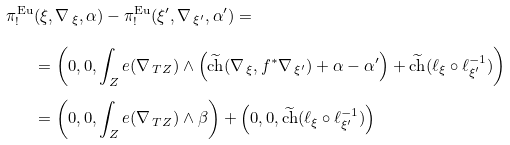<formula> <loc_0><loc_0><loc_500><loc_500>\pi ^ { \text {Eu} } _ { ! } & ( \xi , \nabla _ { \, \xi } , \alpha ) - \pi ^ { \text {Eu} } _ { ! } ( \xi ^ { \prime } , \nabla _ { \, \xi ^ { \prime } } , \alpha ^ { \prime } ) = \\ & = \left ( 0 , 0 , \int _ { Z } e ( \nabla _ { \, T Z } ) \wedge \left ( \widetilde { \text {ch} } ( \nabla _ { \, \xi } , f ^ { * } \nabla _ { \, \xi ^ { \prime } } ) + \alpha - \alpha ^ { \prime } \right ) + \widetilde { \text {ch} } ( \ell _ { \xi } \circ \ell _ { \xi ^ { \prime } } ^ { - 1 } ) \right ) \\ & = \left ( 0 , 0 , \int _ { Z } e ( \nabla _ { \, T Z } ) \wedge \beta \right ) + \left ( 0 , 0 , \widetilde { \text {ch} } ( \ell _ { \xi } \circ \ell _ { \xi ^ { \prime } } ^ { - 1 } ) \right )</formula> 